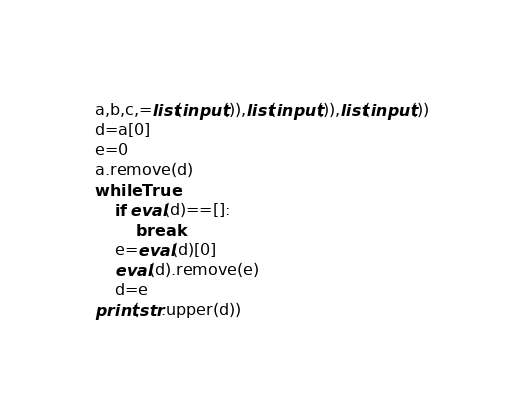Convert code to text. <code><loc_0><loc_0><loc_500><loc_500><_Python_>a,b,c,=list(input()),list(input()),list(input())
d=a[0]
e=0
a.remove(d)
while True:
    if eval(d)==[]:
        break
    e=eval(d)[0]
    eval(d).remove(e)
    d=e
print(str.upper(d))</code> 